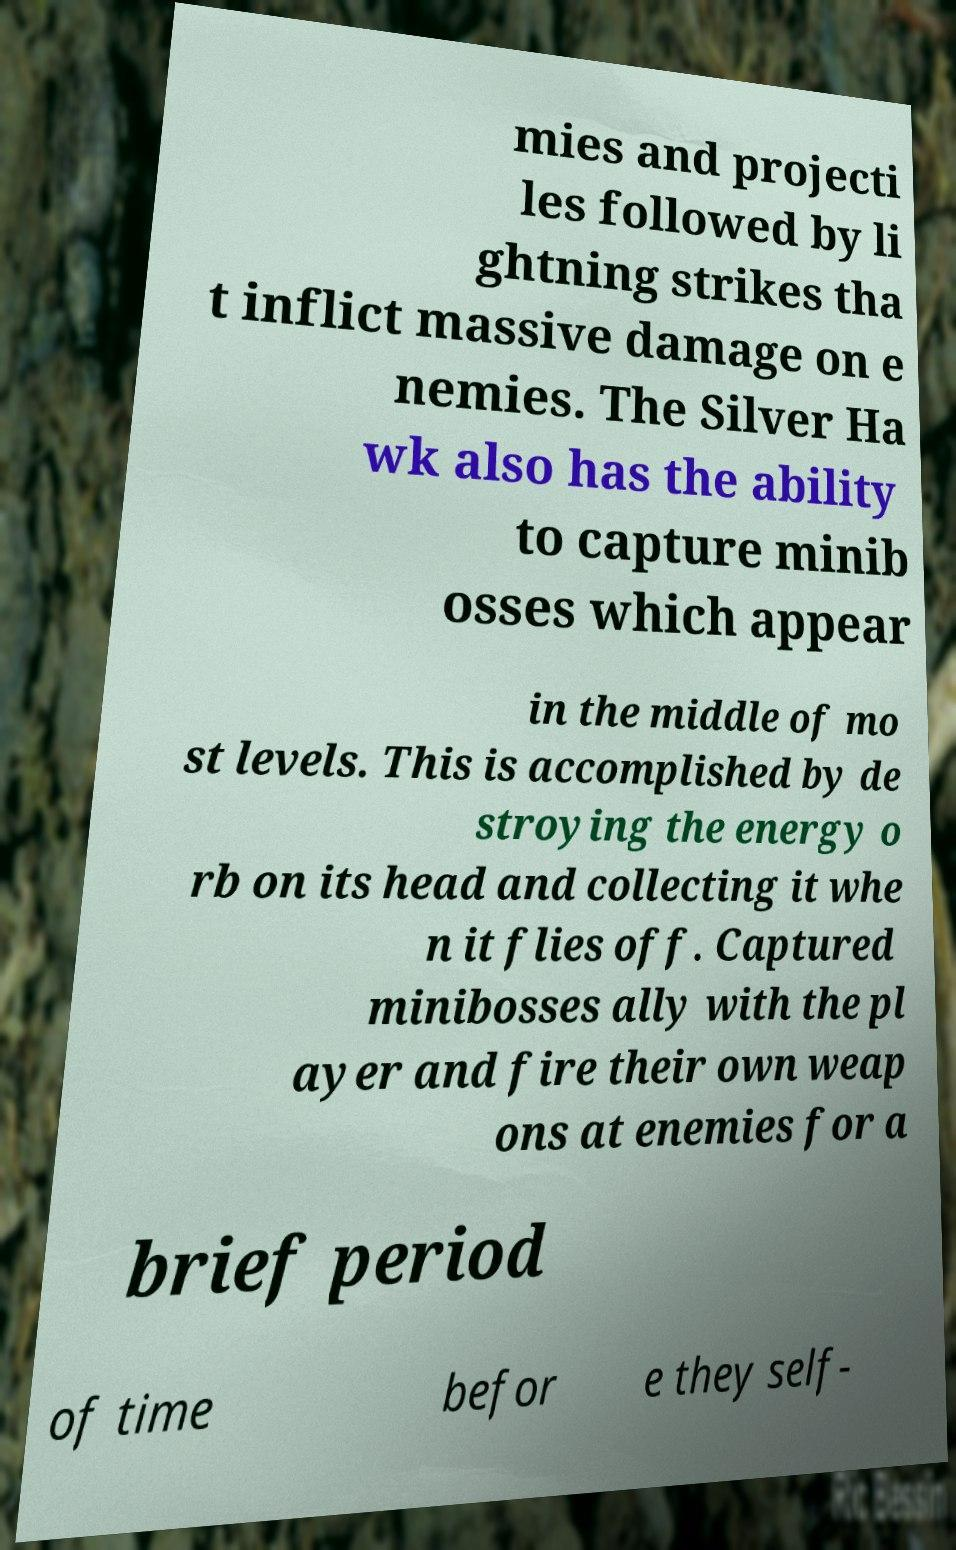Can you read and provide the text displayed in the image?This photo seems to have some interesting text. Can you extract and type it out for me? mies and projecti les followed by li ghtning strikes tha t inflict massive damage on e nemies. The Silver Ha wk also has the ability to capture minib osses which appear in the middle of mo st levels. This is accomplished by de stroying the energy o rb on its head and collecting it whe n it flies off. Captured minibosses ally with the pl ayer and fire their own weap ons at enemies for a brief period of time befor e they self- 